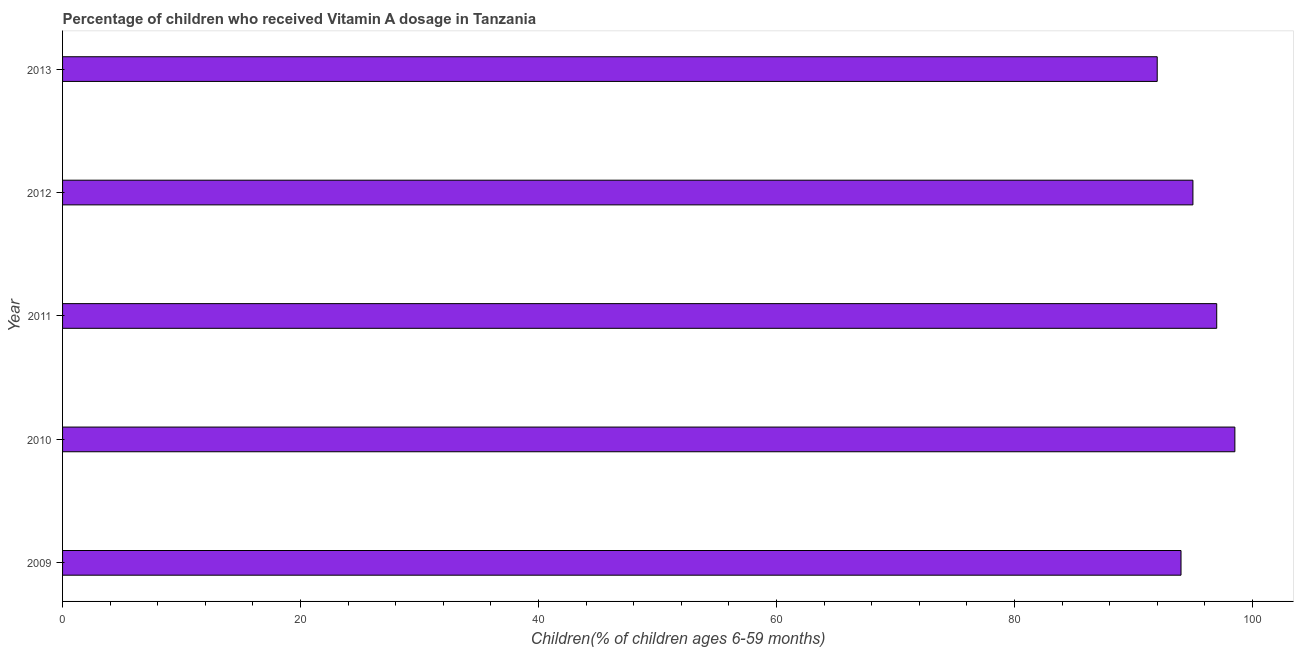Does the graph contain grids?
Keep it short and to the point. No. What is the title of the graph?
Make the answer very short. Percentage of children who received Vitamin A dosage in Tanzania. What is the label or title of the X-axis?
Ensure brevity in your answer.  Children(% of children ages 6-59 months). What is the label or title of the Y-axis?
Your response must be concise. Year. What is the vitamin a supplementation coverage rate in 2010?
Give a very brief answer. 98.53. Across all years, what is the maximum vitamin a supplementation coverage rate?
Offer a very short reply. 98.53. Across all years, what is the minimum vitamin a supplementation coverage rate?
Offer a very short reply. 92. In which year was the vitamin a supplementation coverage rate minimum?
Ensure brevity in your answer.  2013. What is the sum of the vitamin a supplementation coverage rate?
Keep it short and to the point. 476.53. What is the difference between the vitamin a supplementation coverage rate in 2009 and 2013?
Your answer should be very brief. 2. What is the average vitamin a supplementation coverage rate per year?
Your answer should be very brief. 95.31. What is the median vitamin a supplementation coverage rate?
Your answer should be compact. 95. In how many years, is the vitamin a supplementation coverage rate greater than 64 %?
Ensure brevity in your answer.  5. Do a majority of the years between 2013 and 2012 (inclusive) have vitamin a supplementation coverage rate greater than 56 %?
Keep it short and to the point. No. What is the ratio of the vitamin a supplementation coverage rate in 2010 to that in 2011?
Provide a short and direct response. 1.02. Is the difference between the vitamin a supplementation coverage rate in 2011 and 2013 greater than the difference between any two years?
Offer a terse response. No. What is the difference between the highest and the second highest vitamin a supplementation coverage rate?
Keep it short and to the point. 1.53. What is the difference between the highest and the lowest vitamin a supplementation coverage rate?
Make the answer very short. 6.53. How many bars are there?
Your answer should be very brief. 5. How many years are there in the graph?
Provide a succinct answer. 5. What is the difference between two consecutive major ticks on the X-axis?
Give a very brief answer. 20. What is the Children(% of children ages 6-59 months) in 2009?
Make the answer very short. 94. What is the Children(% of children ages 6-59 months) of 2010?
Make the answer very short. 98.53. What is the Children(% of children ages 6-59 months) in 2011?
Keep it short and to the point. 97. What is the Children(% of children ages 6-59 months) in 2012?
Offer a very short reply. 95. What is the Children(% of children ages 6-59 months) of 2013?
Provide a short and direct response. 92. What is the difference between the Children(% of children ages 6-59 months) in 2009 and 2010?
Provide a short and direct response. -4.53. What is the difference between the Children(% of children ages 6-59 months) in 2009 and 2011?
Keep it short and to the point. -3. What is the difference between the Children(% of children ages 6-59 months) in 2009 and 2013?
Provide a succinct answer. 2. What is the difference between the Children(% of children ages 6-59 months) in 2010 and 2011?
Ensure brevity in your answer.  1.53. What is the difference between the Children(% of children ages 6-59 months) in 2010 and 2012?
Provide a succinct answer. 3.53. What is the difference between the Children(% of children ages 6-59 months) in 2010 and 2013?
Offer a very short reply. 6.53. What is the difference between the Children(% of children ages 6-59 months) in 2011 and 2012?
Provide a short and direct response. 2. What is the difference between the Children(% of children ages 6-59 months) in 2012 and 2013?
Keep it short and to the point. 3. What is the ratio of the Children(% of children ages 6-59 months) in 2009 to that in 2010?
Provide a short and direct response. 0.95. What is the ratio of the Children(% of children ages 6-59 months) in 2009 to that in 2011?
Your answer should be compact. 0.97. What is the ratio of the Children(% of children ages 6-59 months) in 2010 to that in 2011?
Offer a terse response. 1.02. What is the ratio of the Children(% of children ages 6-59 months) in 2010 to that in 2013?
Give a very brief answer. 1.07. What is the ratio of the Children(% of children ages 6-59 months) in 2011 to that in 2012?
Provide a succinct answer. 1.02. What is the ratio of the Children(% of children ages 6-59 months) in 2011 to that in 2013?
Your response must be concise. 1.05. What is the ratio of the Children(% of children ages 6-59 months) in 2012 to that in 2013?
Your answer should be very brief. 1.03. 